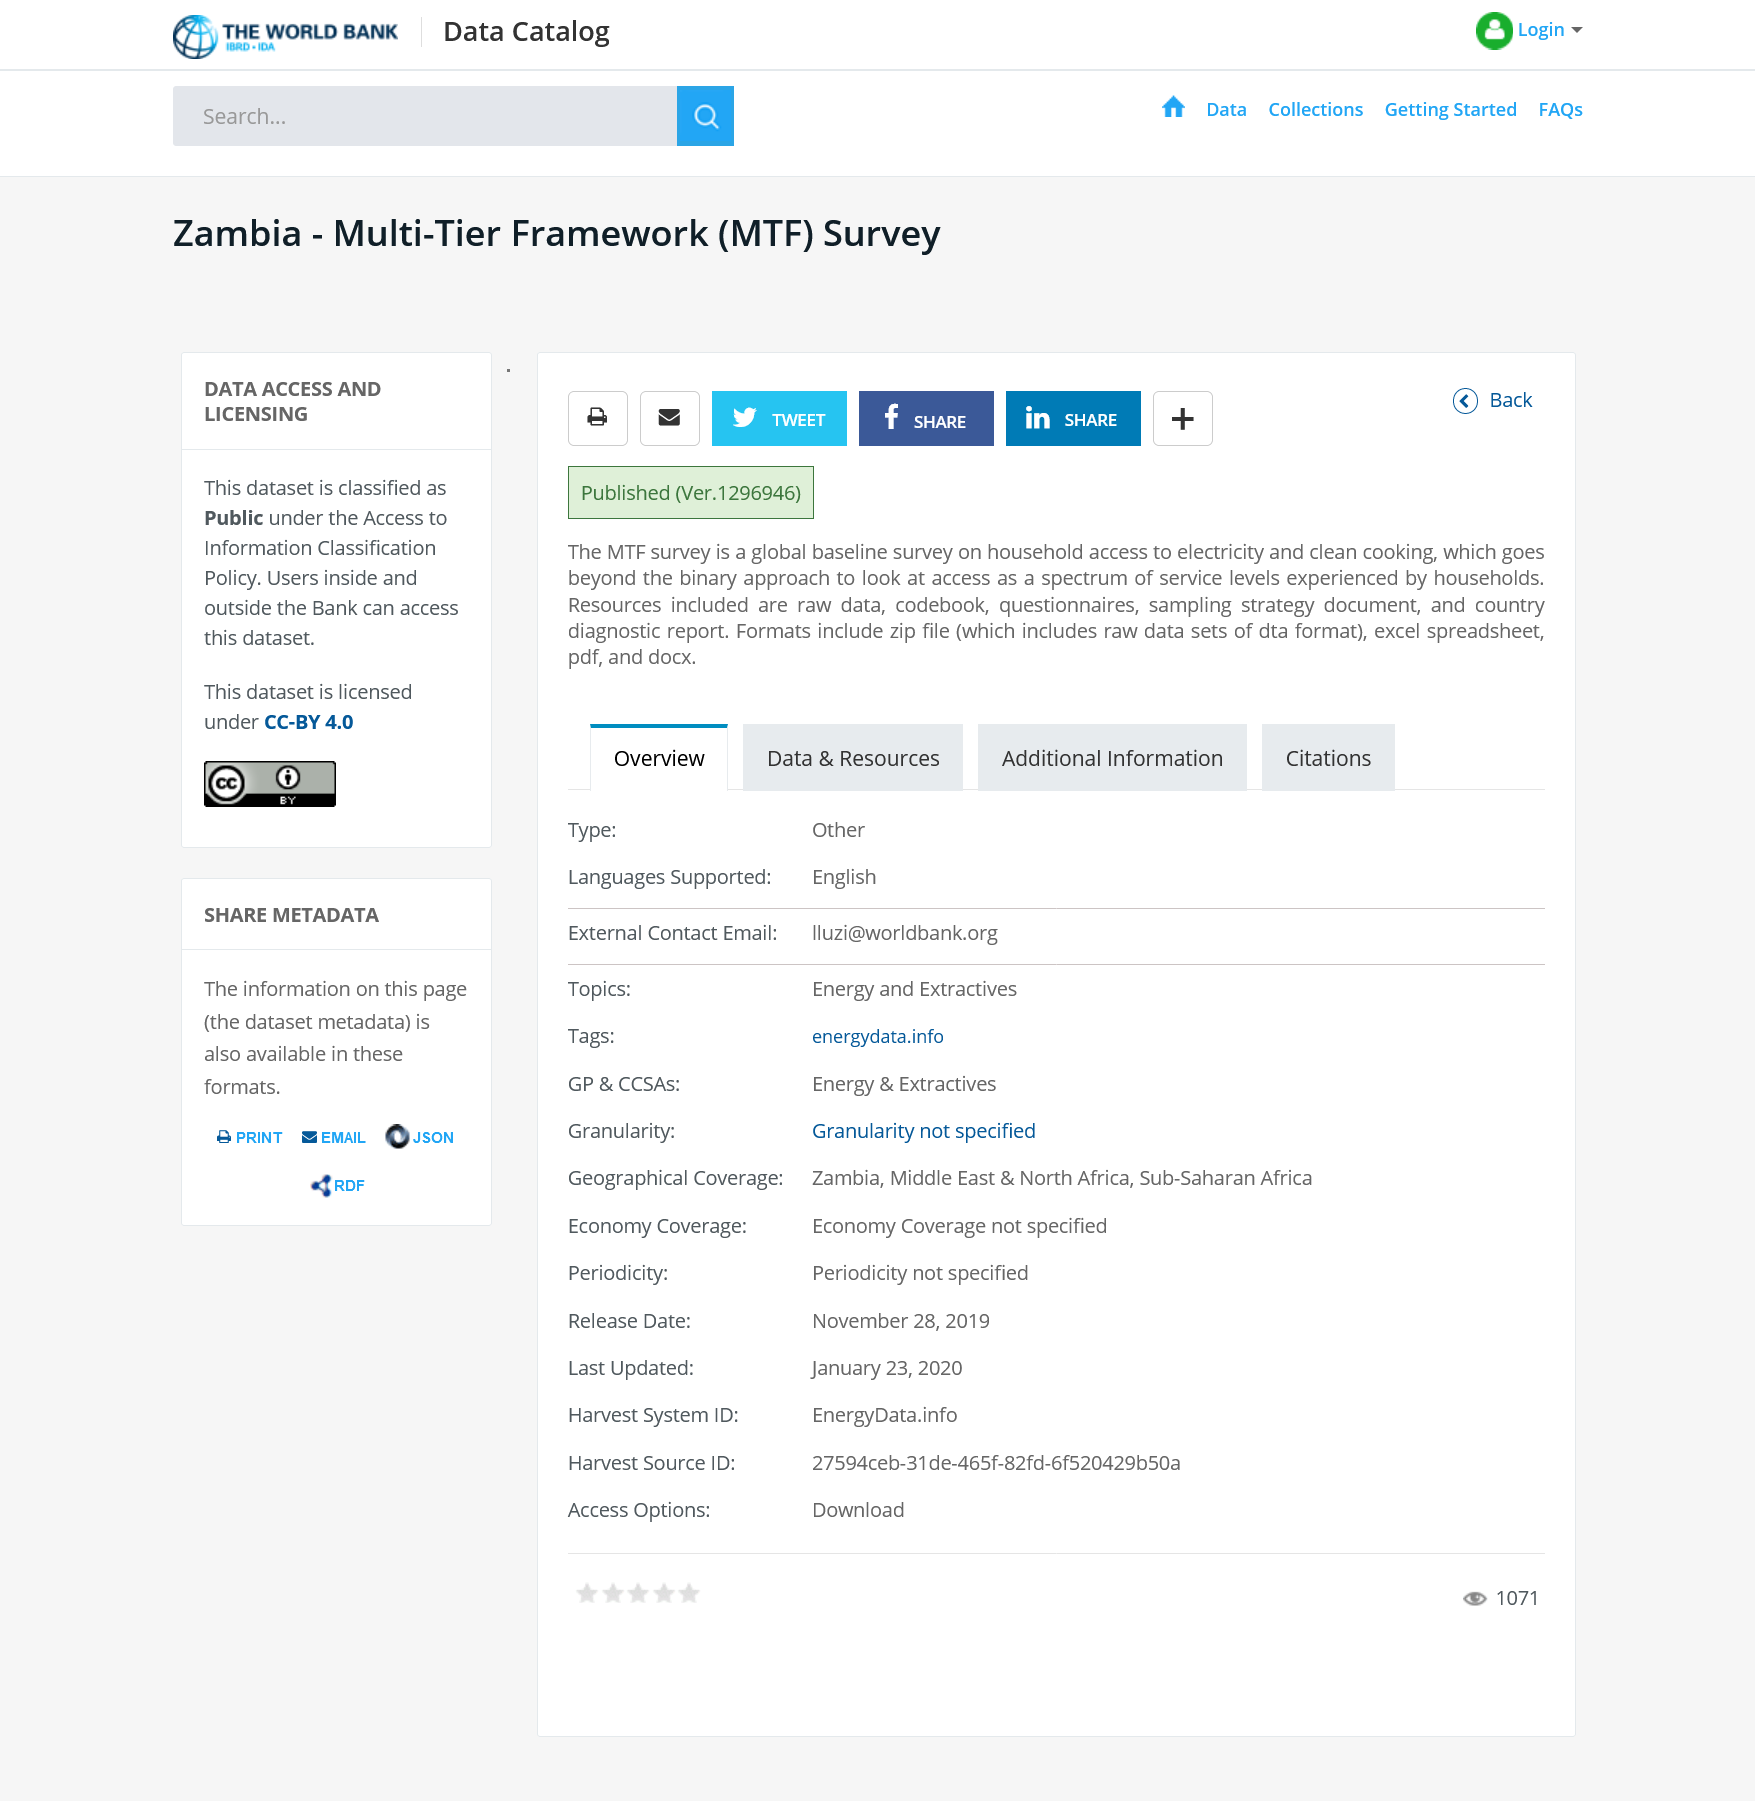Outline some significant characteristics in this image. The MTF survey includes raw data, a codebook, questionnaires, a sampling strategy document, and a country diagnostic report as its resources. The dataset can be accessed by both Bank employees and external users who meet the specified eligibility criteria. The MTF survey is a global baseline survey on household access to electricity and clean cooking. 